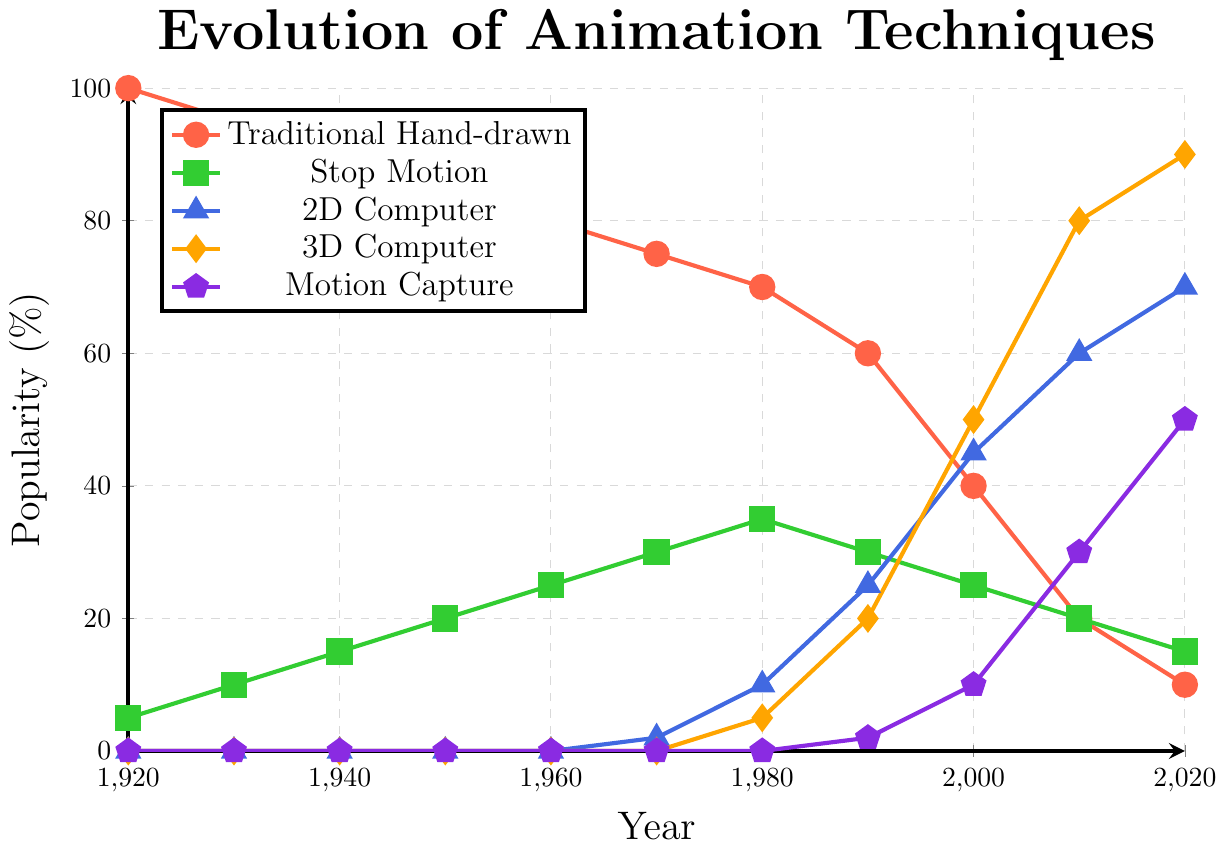How has the popularity of traditional hand-drawn animation changed from 1920 to 2020? The popularity of traditional hand-drawn animation has continuously decreased over the century. It started at 100% in 1920 and declined steadily to 10% by 2020.
Answer: It declined Which type of animation had the highest popularity in 2010? In 2010, the 3D Computer animation technique had the highest popularity, as it reached 80% while other techniques had lower percentages.
Answer: 3D Computer Between which years did 3D computer animation see the most significant increase in popularity? 3D computer animation saw the most significant increase from 2000 to 2010, where its popularity jumped from 50% to 80%.
Answer: 2000 to 2010 By how much did the popularity of stop motion animation change from 1940 to 1990? The popularity of stop motion in 1940 was 15%, and in 1990 it was 30%. The change is calculated as 30% - 15% = 15%.
Answer: 15% How does the popularity of 2D computer animation in 2020 compare to that in 1970? In 1970, 2D computer animation was at 2%, while in 2020 it was at 70%. This shows a significant increase of 68%.
Answer: It increased by 68% What is the average popularity of motion capture animation over the decades available? Motion capture animation has values of 0, 0, 0, 0, 0, 0, 2, 10, 30, and 50 for the decades available. Adding these gives 92. Dividing by the 10 data points gives an average of 9.2.
Answer: 9.2% What's the sum of the popularity percentages for all animation techniques in 2020? The percentages in 2020 are: 10 (Traditional Hand-drawn), 15 (Stop Motion), 70 (2D Computer), 90 (3D Computer), and 50 (Motion Capture). Sum = 10 + 15 + 70 + 90 + 50 = 235.
Answer: 235% Which two animation techniques had equal popularity in 1980, and what was the value? In 1980, both Stop Motion and 3D Computer animation had a popularity of 35%.
Answer: Stop Motion and 3D Computer, 35% When did 2D computer animation first surpass traditional hand-drawn animation in popularity? 2D computer animation first surpassed traditional hand-drawn animation in popularity in 2010, with 60% for 2D and 20% for hand-drawn.
Answer: 2010 How many years did it take for motion capture to reach 50% popularity from its introduction in the dataset? Motion capture was introduced in 1990 with 2%, reaching 50% in 2020. Therefore, it took 2020 - 1990 = 30 years.
Answer: 30 years 